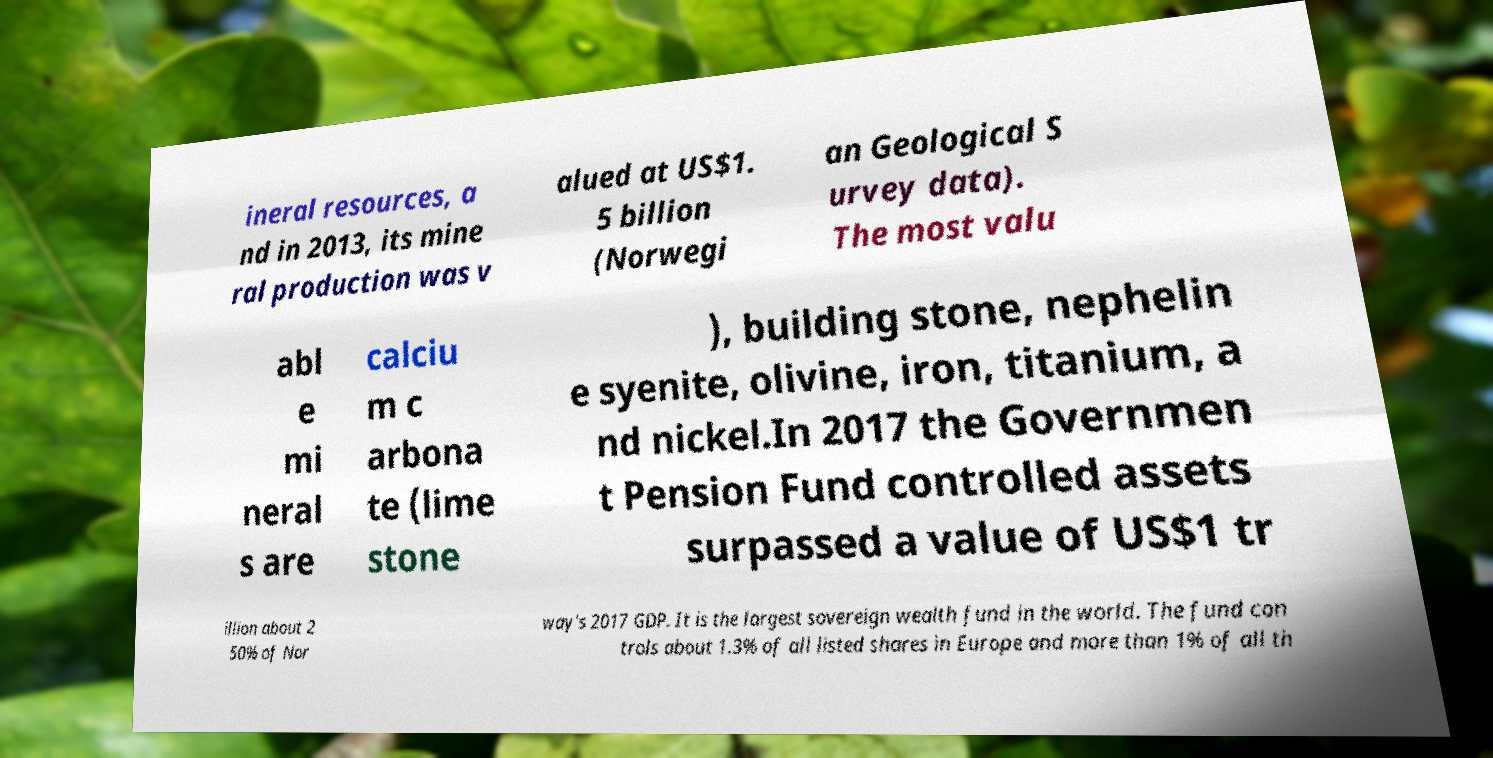I need the written content from this picture converted into text. Can you do that? ineral resources, a nd in 2013, its mine ral production was v alued at US$1. 5 billion (Norwegi an Geological S urvey data). The most valu abl e mi neral s are calciu m c arbona te (lime stone ), building stone, nephelin e syenite, olivine, iron, titanium, a nd nickel.In 2017 the Governmen t Pension Fund controlled assets surpassed a value of US$1 tr illion about 2 50% of Nor way's 2017 GDP. It is the largest sovereign wealth fund in the world. The fund con trols about 1.3% of all listed shares in Europe and more than 1% of all th 